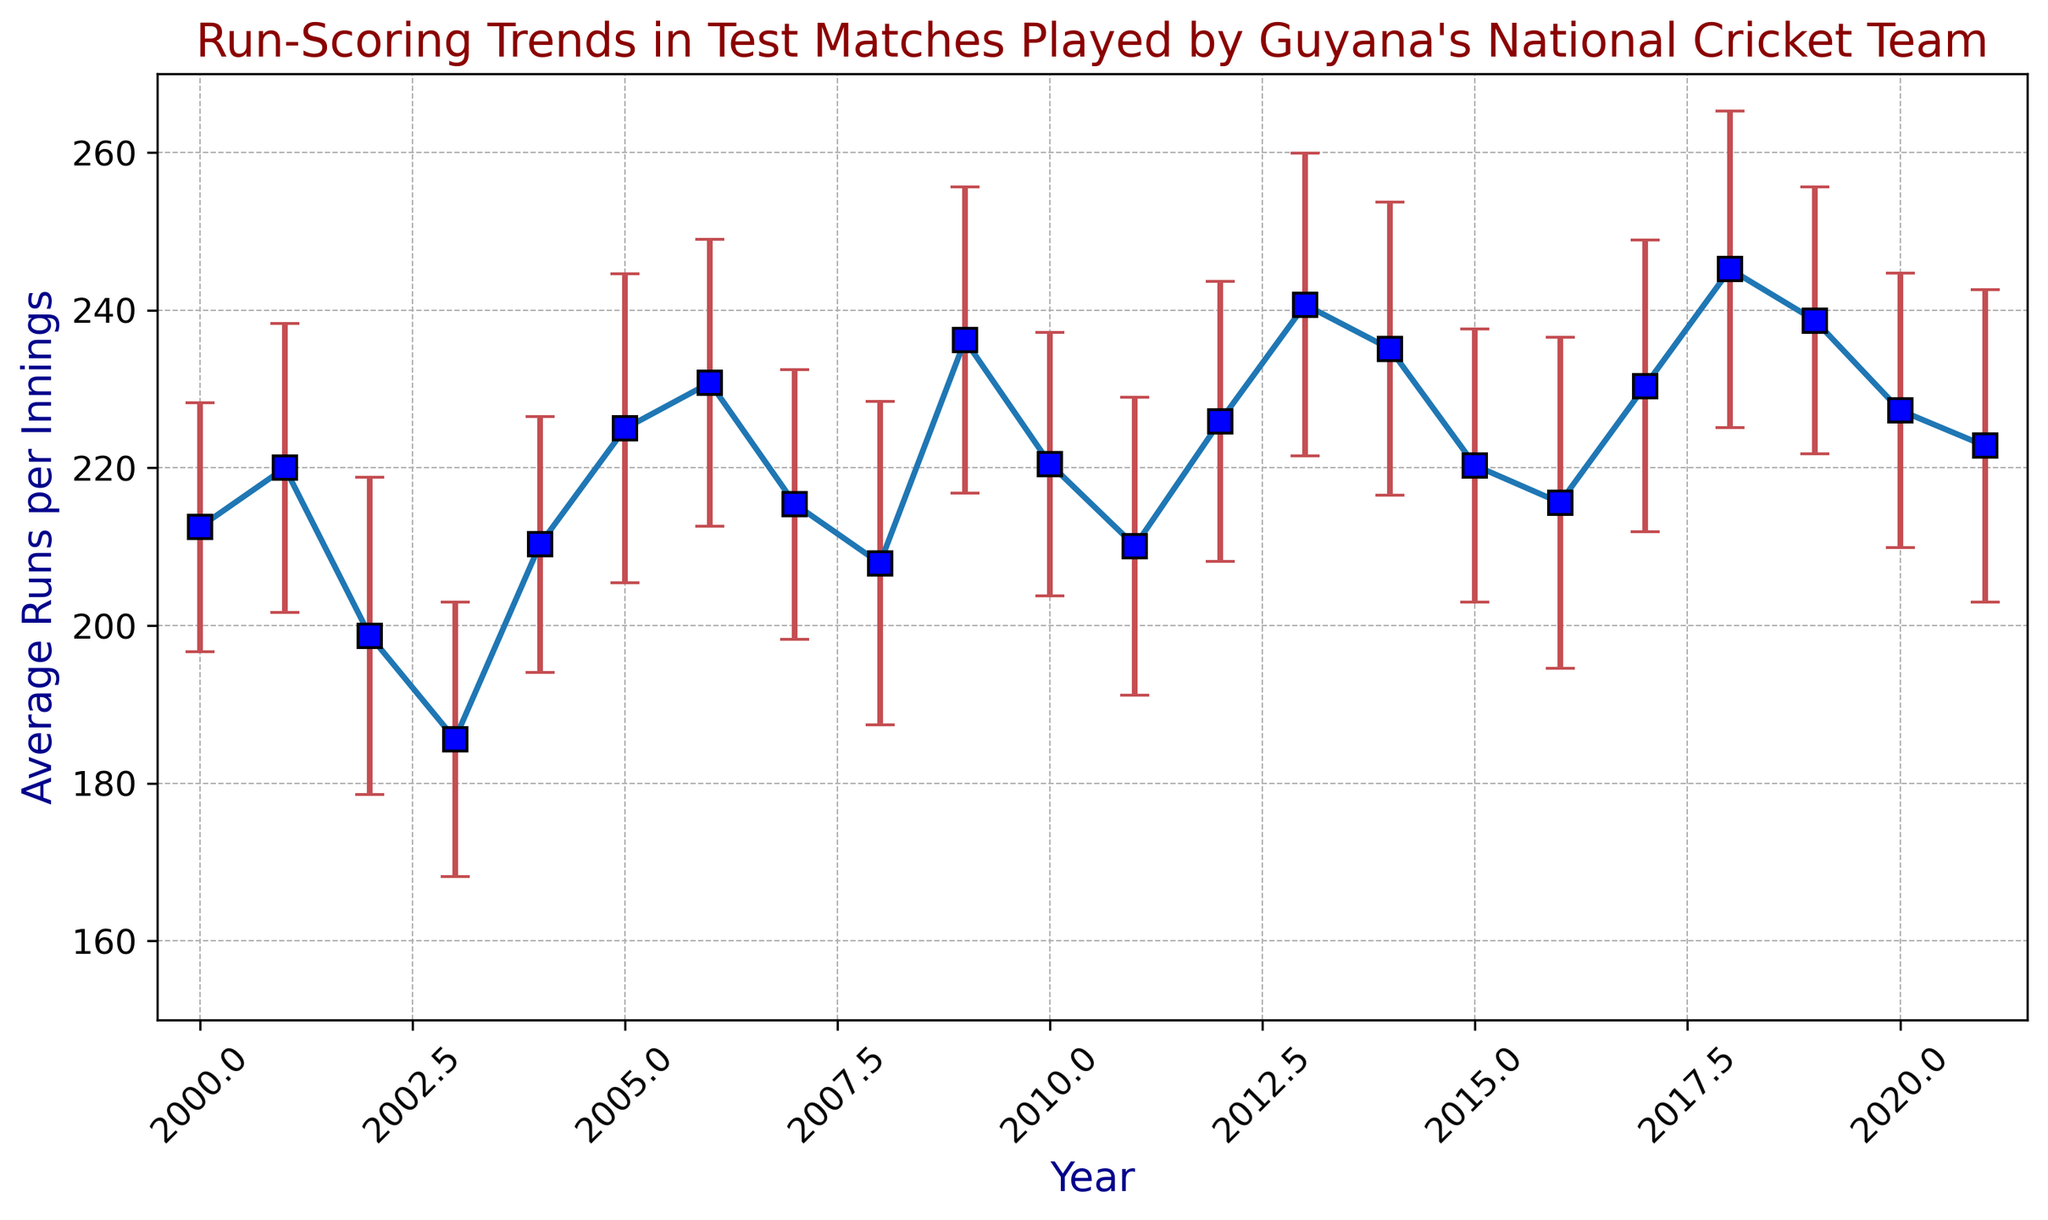What is the highest average run per innings recorded? Look for the highest point on the y-axis labels representing "Average Runs per Innings" from the given years. The highest value is approximately during 2018.
Answer: 245.2 In which year did the team have the lowest average runs per innings? Identify the lowest value on the y-axis for "Average Runs per Innings" and note the corresponding year on the x-axis. This occurs in 2003.
Answer: 185.6 How does the average runs per innings in 2013 compare to that in 2014? Locate the points for 2013 and 2014 and compare their y-axis values. In 2013, the value is higher than in 2014.
Answer: Higher in 2013 What is the difference in average runs per innings between 2006 and 2017? Find the "Average Runs per Innings" for both years (230.8 in 2006 and 230.4 in 2017). Subtract the latter from the former to get the difference.
Answer: 0.4 During which years do the error bars overlap, indicating a possible consistency in performance? Observe the range of the error bars and note years where the error margins of adjacent years intersect, such as between 2005 and 2006.
Answer: 2005-2006, 2010-2011 Which year had the most significant error margin, and what was its value? Look for the year with the longest error bars (vertical bars) and identify the value associated with it. The most significant error margin occurs in 2016 with a value of 21.0.
Answer: 2016, 21.0 What is the average of the average runs per innings for the three years with the top highest averages? Identify the top three highest average runs per innings (2018 with 245.2, 2013 with 240.7, 2019 with 238.7), sum them, and divide by three: (245.2 + 240.7 + 238.7)/3.
Answer: 241.53 How much did the average runs per innings increase from 2003 to 2004? Subtract the value in 2003 (185.6) from the value in 2004 (210.3): 210.3 - 185.6.
Answer: 24.7 